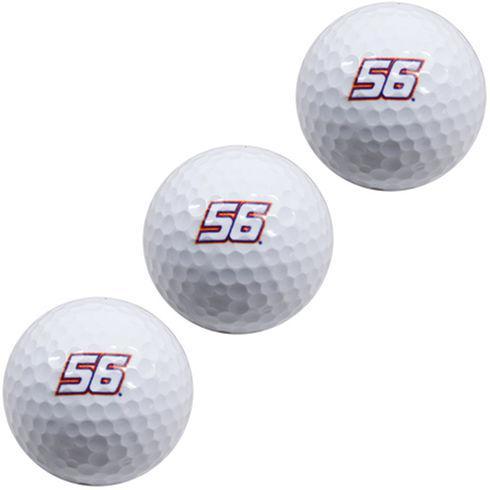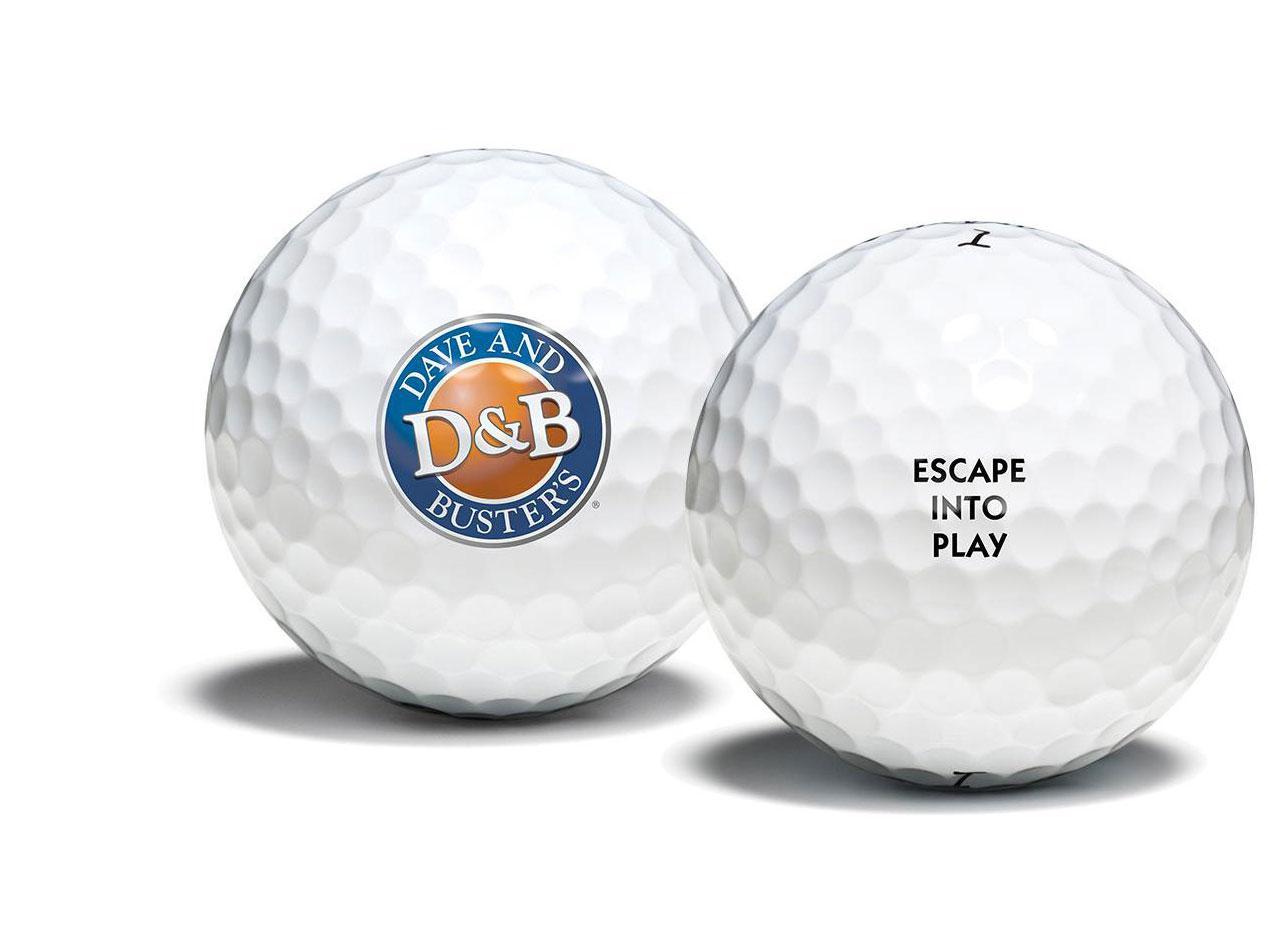The first image is the image on the left, the second image is the image on the right. For the images shown, is this caption "At least one image contains a single whole golf ball." true? Answer yes or no. No. 